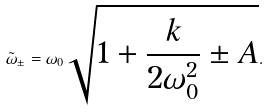<formula> <loc_0><loc_0><loc_500><loc_500>\tilde { \omega } _ { \pm } = \omega _ { 0 } \sqrt { 1 + \frac { k } { 2 \omega _ { 0 } ^ { 2 } } \pm A } .</formula> 